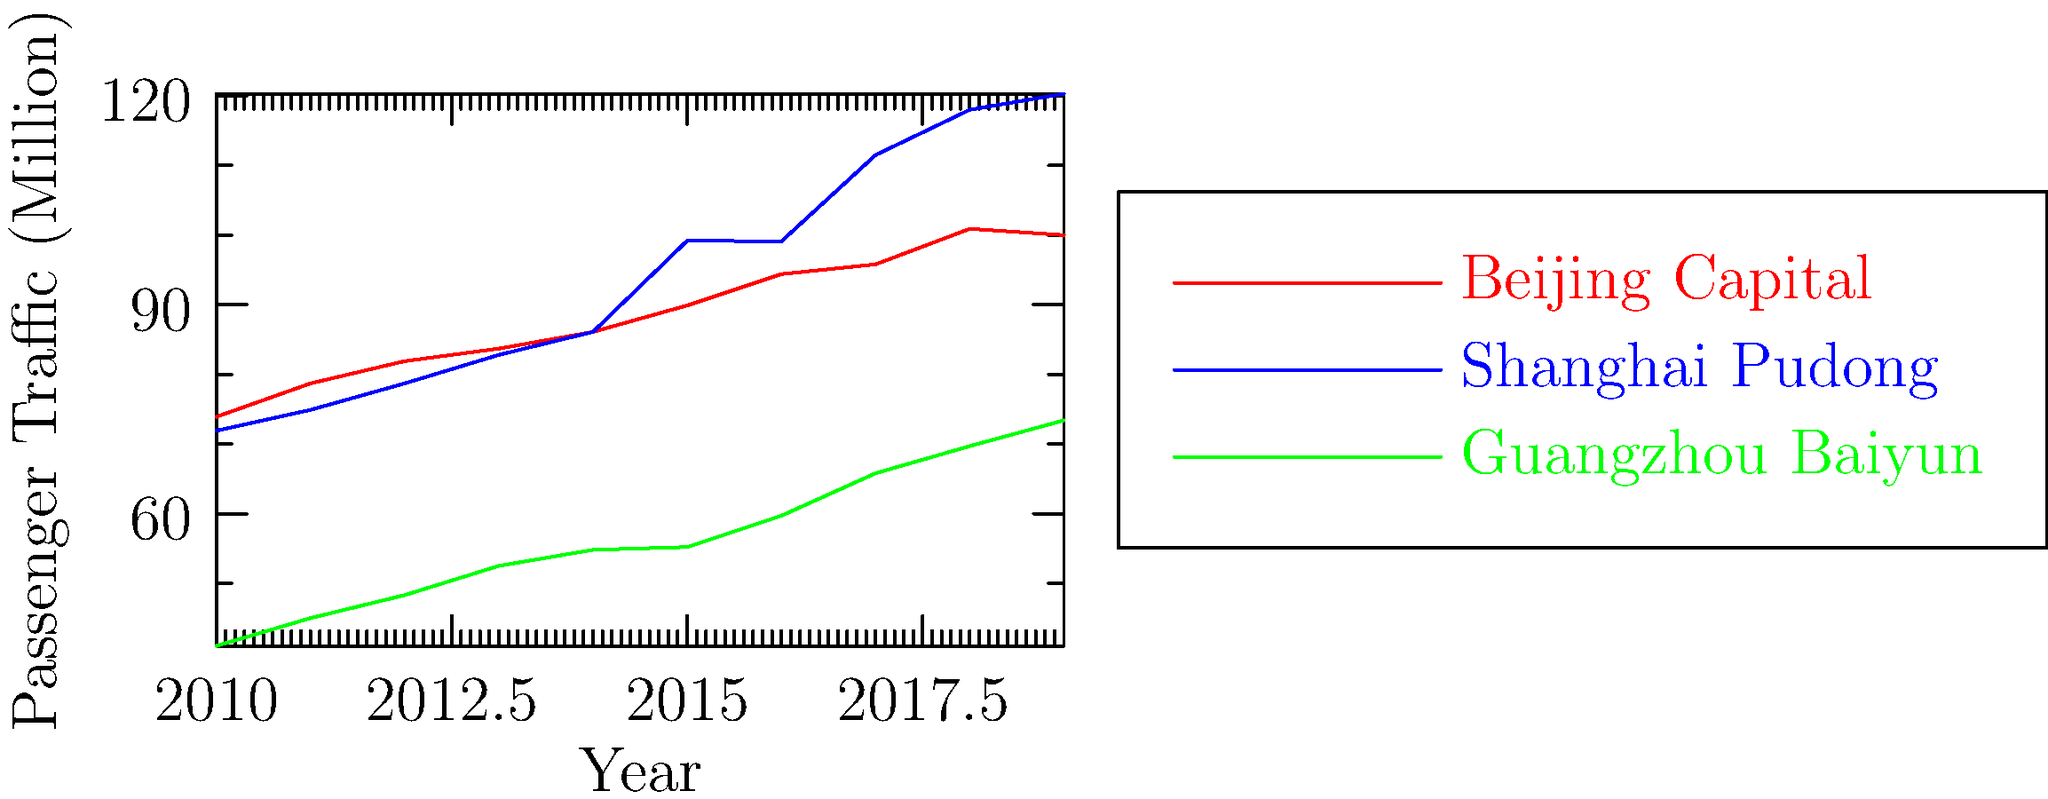Based on the graph showing passenger traffic trends at three major Chinese airports from 2010 to 2019, which airport experienced the most significant growth in passenger numbers, and what factors might have contributed to this growth pattern? To determine which airport experienced the most significant growth, we need to analyze the trends for each airport:

1. Beijing Capital Airport:
   - 2010: 73.9 million passengers
   - 2019: 100.0 million passengers
   - Growth: 26.1 million (35.3% increase)

2. Shanghai Pudong Airport:
   - 2010: 71.9 million passengers
   - 2019: 120.3 million passengers
   - Growth: 48.4 million (67.3% increase)

3. Guangzhou Baiyun Airport:
   - 2010: 41.0 million passengers
   - 2019: 73.4 million passengers
   - Growth: 32.4 million (79.0% increase)

Shanghai Pudong Airport experienced the most significant absolute growth (48.4 million passengers), while Guangzhou Baiyun Airport had the highest percentage growth (79.0%).

Factors contributing to Shanghai Pudong's growth:

1. Economic development: Shanghai's rapid economic growth as a global financial hub.
2. Expansion of international routes: Increased connectivity to global destinations.
3. Infrastructure improvements: Terminal expansions and runway additions.
4. Hub strategy: Development as a major connecting hub for international flights.
5. Population growth: Increasing demand from the growing urban population.
6. Tourism: Shanghai's growing popularity as a tourist destination.

While Shanghai Pudong showed the largest absolute growth, it's important to note that Guangzhou Baiyun's percentage growth was higher, indicating significant development in the Pearl River Delta region.
Answer: Shanghai Pudong Airport (48.4 million passenger increase) 